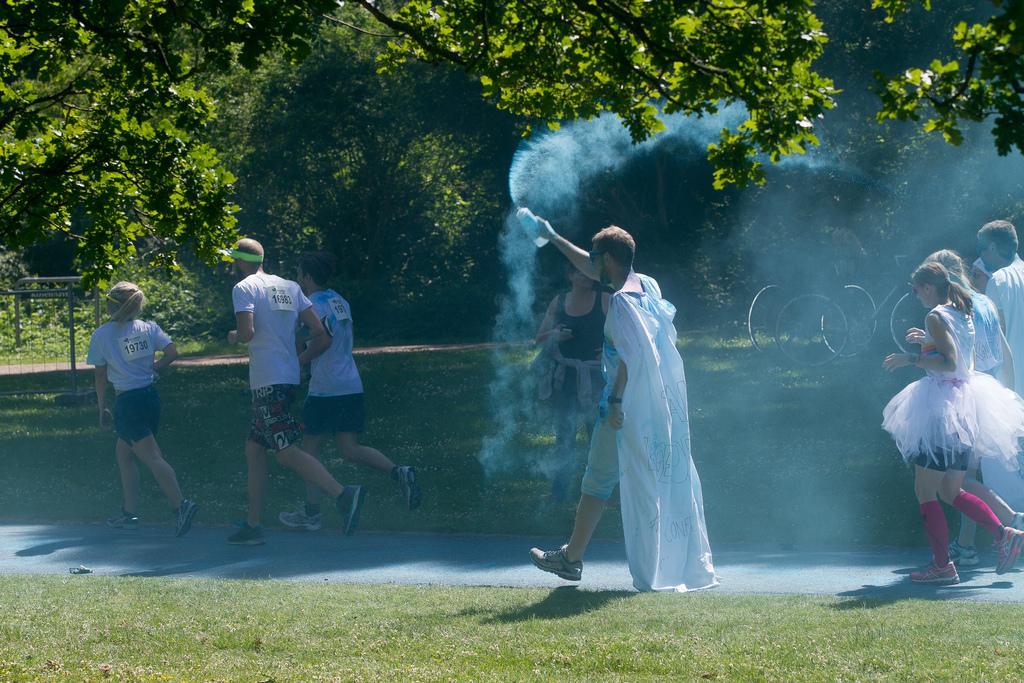Can you describe this image briefly? In this image I can see the group of people with different color dresses. I can see one person holding the bottle. I can see the smoke in the air. In the background there are many trees and the bicycles. 